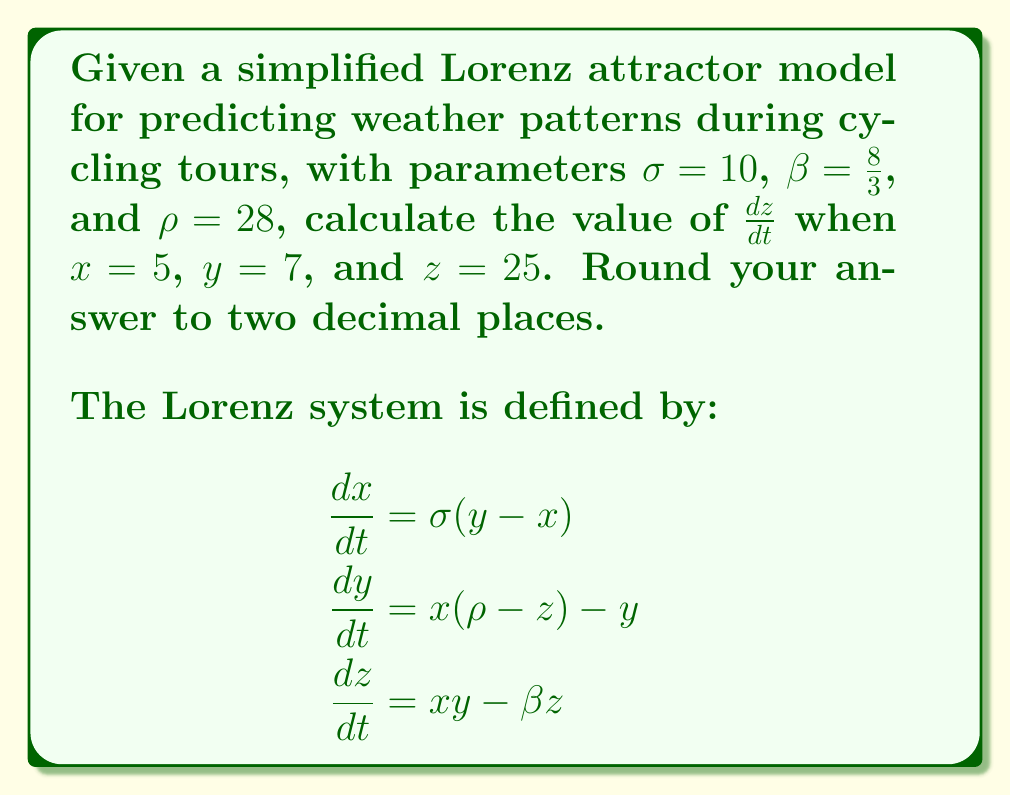Solve this math problem. To solve this problem, we'll follow these steps:

1) We are given the Lorenz system equations and the values for the parameters:
   $\sigma = 10$, $\beta = \frac{8}{3}$, and $\rho = 28$

2) We're asked to calculate $\frac{dz}{dt}$, so we'll focus on the third equation:
   
   $$\frac{dz}{dt} = xy - \beta z$$

3) We're given the values for $x$, $y$, and $z$:
   $x = 5$, $y = 7$, and $z = 25$

4) Let's substitute these values into our equation:

   $$\frac{dz}{dt} = (5)(7) - \frac{8}{3}(25)$$

5) First, let's calculate $xy$:
   $5 * 7 = 35$

6) Now, let's calculate $\beta z$:
   $\frac{8}{3} * 25 = \frac{200}{3} \approx 66.67$

7) Putting it all together:

   $$\frac{dz}{dt} = 35 - 66.67 = -31.67$$

8) Rounding to two decimal places:

   $$\frac{dz}{dt} \approx -31.67$$

This negative value indicates that $z$ is decreasing at this point in the system, which could represent a change in weather conditions that might affect cycling tour schedules.
Answer: $-31.67$ 